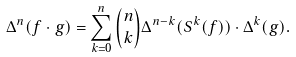Convert formula to latex. <formula><loc_0><loc_0><loc_500><loc_500>\Delta ^ { n } ( f \cdot g ) = \sum _ { k = 0 } ^ { n } { n \choose k } \Delta ^ { n - k } ( S ^ { k } ( f ) ) \cdot \Delta ^ { k } ( g ) .</formula> 